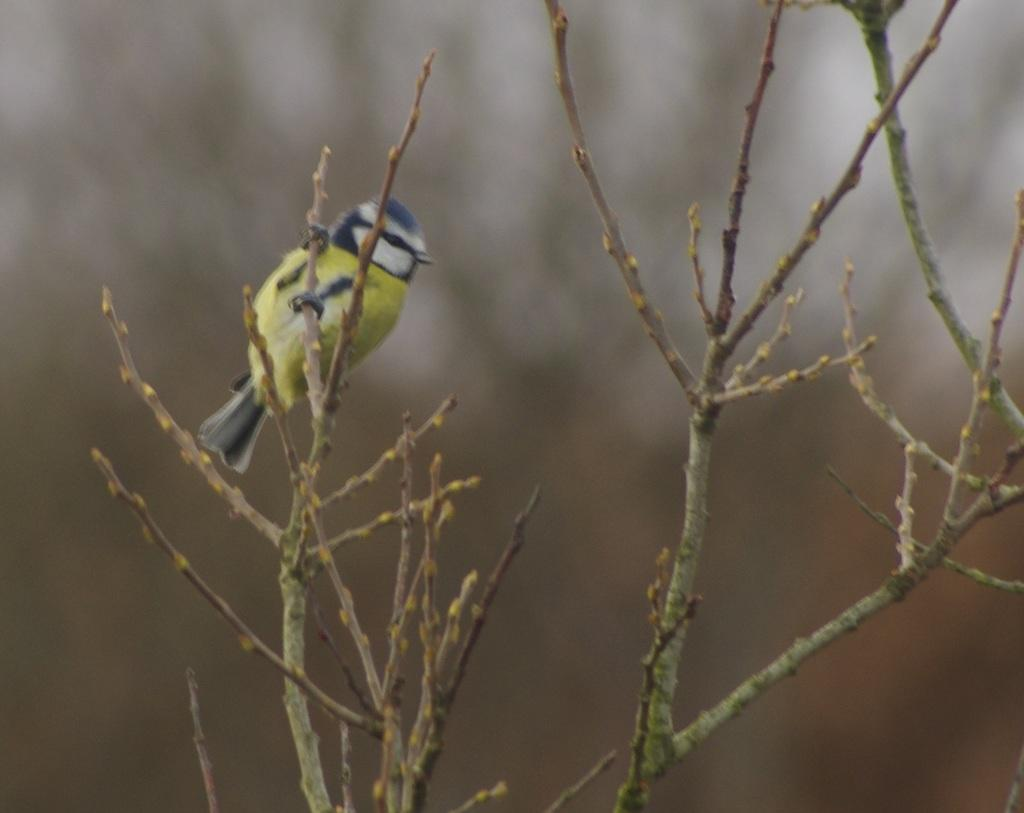What type of animal can be seen in the image? There is a bird in the image. Where is the bird located in the image? The bird is sitting on the stem of a plant. Can you describe the background of the image? The background of the image is blurry. How does the bird maintain its quiet demeanor in the image? The bird's demeanor is not mentioned in the image, and there is no indication of its noise level. 